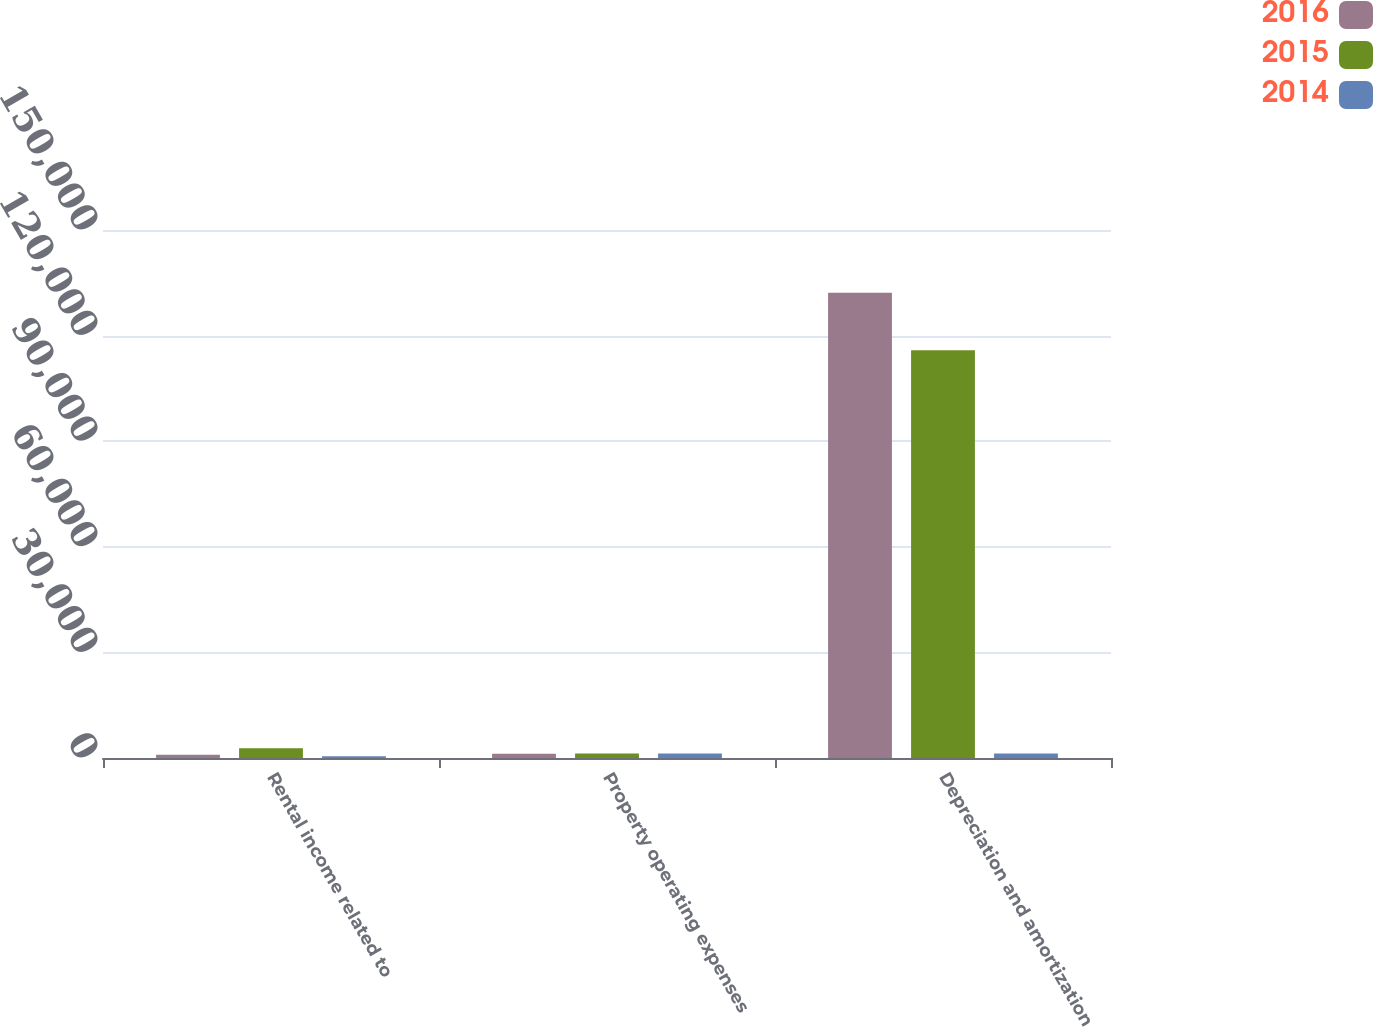Convert chart to OTSL. <chart><loc_0><loc_0><loc_500><loc_500><stacked_bar_chart><ecel><fcel>Rental income related to<fcel>Property operating expenses<fcel>Depreciation and amortization<nl><fcel>2016<fcel>919<fcel>1241<fcel>132141<nl><fcel>2015<fcel>2746<fcel>1272<fcel>115855<nl><fcel>2014<fcel>509<fcel>1248<fcel>1260<nl></chart> 